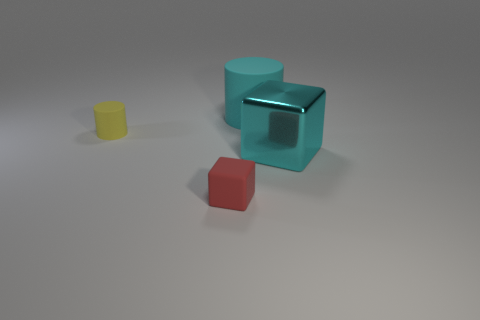How many things are cyan things behind the large cyan cube or metal objects?
Your response must be concise. 2. How many yellow things are the same material as the small cylinder?
Your answer should be compact. 0. There is a rubber thing that is the same color as the big shiny block; what is its shape?
Provide a succinct answer. Cylinder. Are there the same number of tiny rubber cylinders that are behind the small yellow cylinder and red metallic spheres?
Give a very brief answer. Yes. What size is the cyan thing in front of the yellow matte object?
Offer a very short reply. Large. What number of large objects are red shiny cubes or matte blocks?
Your response must be concise. 0. There is another large thing that is the same shape as the yellow matte object; what is its color?
Offer a terse response. Cyan. Do the cyan matte object and the yellow object have the same size?
Offer a very short reply. No. What number of objects are either large blue cubes or big cyan objects behind the cyan cube?
Provide a succinct answer. 1. The rubber cylinder left of the matte thing in front of the yellow cylinder is what color?
Give a very brief answer. Yellow. 